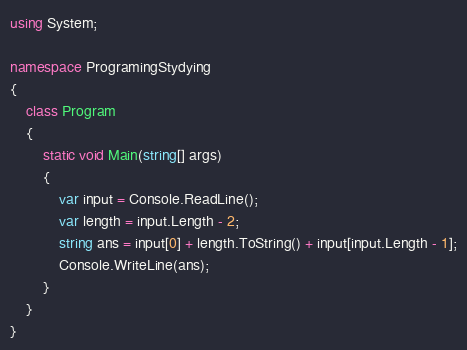Convert code to text. <code><loc_0><loc_0><loc_500><loc_500><_C#_>using System;

namespace ProgramingStydying
{
    class Program
    {
        static void Main(string[] args)
        {
            var input = Console.ReadLine();
            var length = input.Length - 2;
            string ans = input[0] + length.ToString() + input[input.Length - 1];
            Console.WriteLine(ans);
        }
    }
}
</code> 